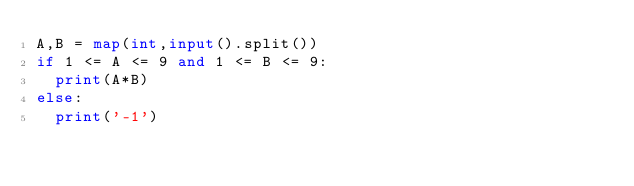Convert code to text. <code><loc_0><loc_0><loc_500><loc_500><_Python_>A,B = map(int,input().split())
if 1 <= A <= 9 and 1 <= B <= 9:
  print(A*B)
else:
  print('-1')</code> 